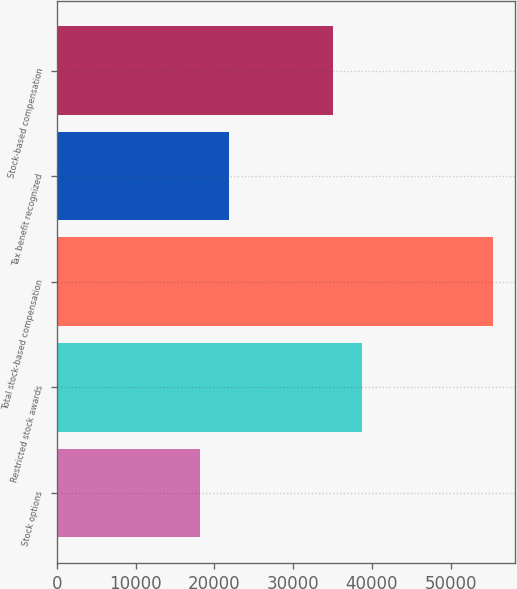<chart> <loc_0><loc_0><loc_500><loc_500><bar_chart><fcel>Stock options<fcel>Restricted stock awards<fcel>Total stock-based compensation<fcel>Tax benefit recognized<fcel>Stock-based compensation<nl><fcel>18202<fcel>38803.7<fcel>55369<fcel>21918.7<fcel>35087<nl></chart> 